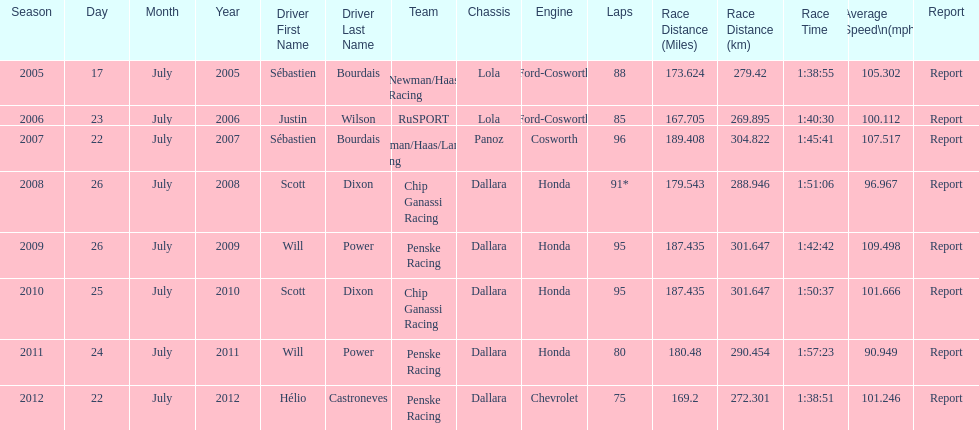How many times did sébastien bourdais win the champ car world series between 2005 and 2007? 2. 